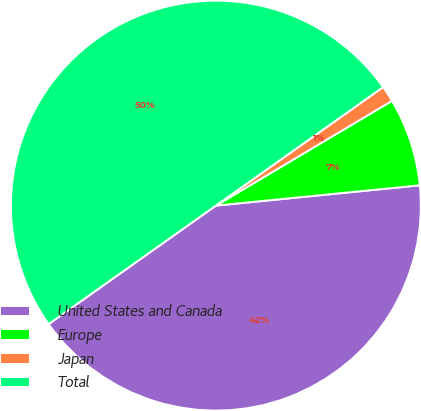Convert chart to OTSL. <chart><loc_0><loc_0><loc_500><loc_500><pie_chart><fcel>United States and Canada<fcel>Europe<fcel>Japan<fcel>Total<nl><fcel>41.77%<fcel>6.96%<fcel>1.27%<fcel>50.0%<nl></chart> 